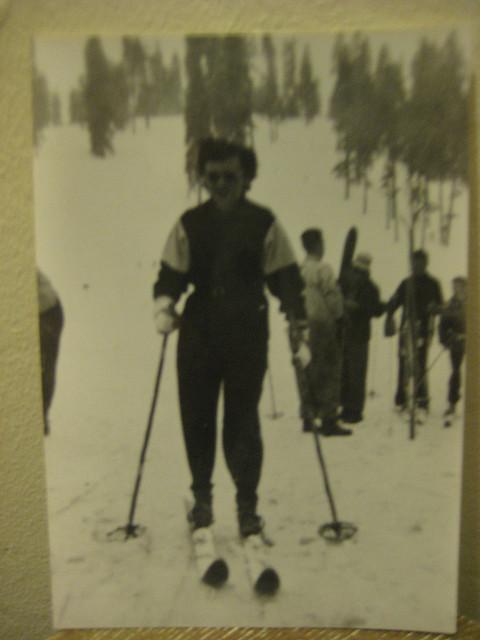Is she wearing glasses?
Give a very brief answer. Yes. What is she holding in her hands?
Give a very brief answer. Poles. Is the person carrying a backpack?
Concise answer only. No. Is this a modern photo?
Quick response, please. No. 